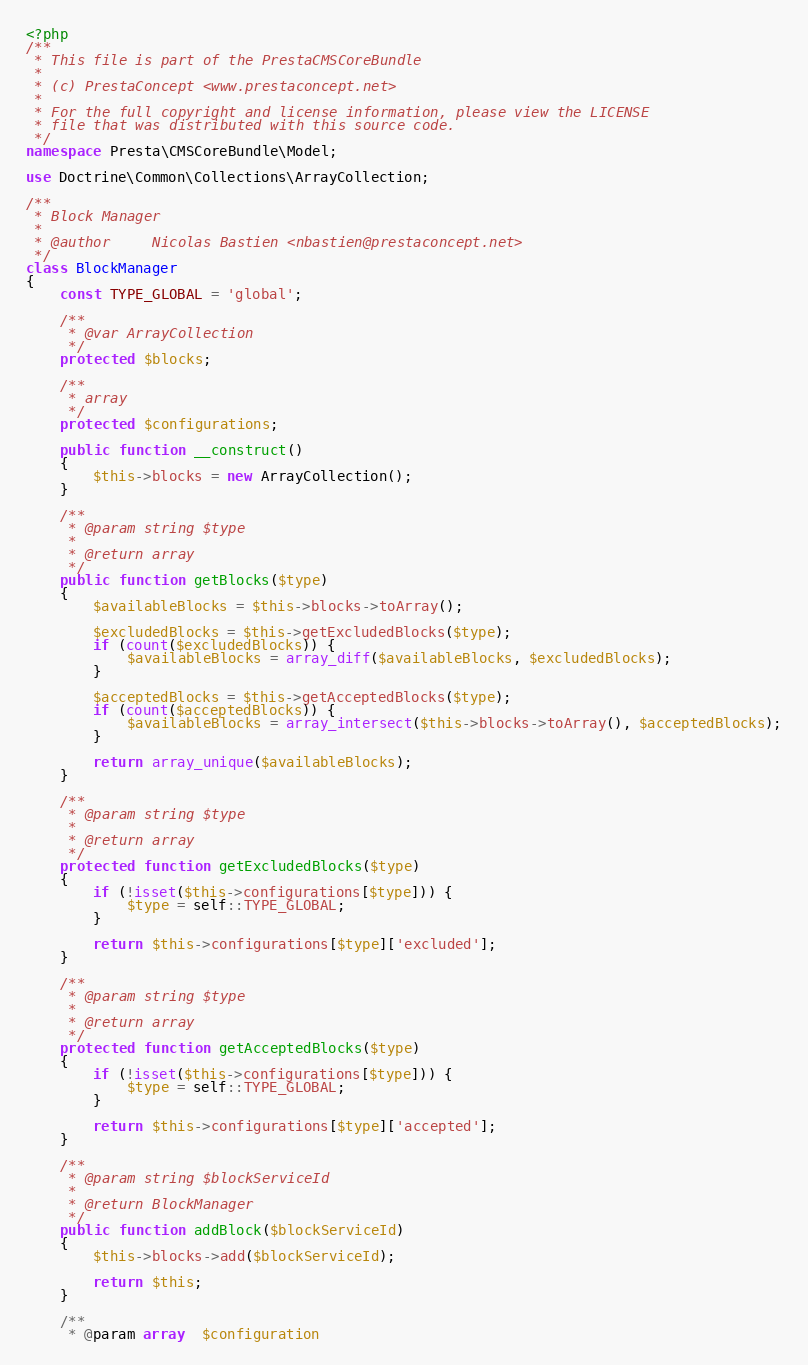Convert code to text. <code><loc_0><loc_0><loc_500><loc_500><_PHP_><?php
/**
 * This file is part of the PrestaCMSCoreBundle
 *
 * (c) PrestaConcept <www.prestaconcept.net>
 *
 * For the full copyright and license information, please view the LICENSE
 * file that was distributed with this source code.
 */
namespace Presta\CMSCoreBundle\Model;

use Doctrine\Common\Collections\ArrayCollection;

/**
 * Block Manager
 *
 * @author     Nicolas Bastien <nbastien@prestaconcept.net>
 */
class BlockManager
{
    const TYPE_GLOBAL = 'global';

    /**
     * @var ArrayCollection
     */
    protected $blocks;

    /**
     * array
     */
    protected $configurations;

    public function __construct()
    {
        $this->blocks = new ArrayCollection();
    }

    /**
     * @param string $type
     *
     * @return array
     */
    public function getBlocks($type)
    {
        $availableBlocks = $this->blocks->toArray();

        $excludedBlocks = $this->getExcludedBlocks($type);
        if (count($excludedBlocks)) {
            $availableBlocks = array_diff($availableBlocks, $excludedBlocks);
        }

        $acceptedBlocks = $this->getAcceptedBlocks($type);
        if (count($acceptedBlocks)) {
            $availableBlocks = array_intersect($this->blocks->toArray(), $acceptedBlocks);
        }

        return array_unique($availableBlocks);
    }

    /**
     * @param string $type
     *
     * @return array
     */
    protected function getExcludedBlocks($type)
    {
        if (!isset($this->configurations[$type])) {
            $type = self::TYPE_GLOBAL;
        }

        return $this->configurations[$type]['excluded'];
    }

    /**
     * @param string $type
     *
     * @return array
     */
    protected function getAcceptedBlocks($type)
    {
        if (!isset($this->configurations[$type])) {
            $type = self::TYPE_GLOBAL;
        }

        return $this->configurations[$type]['accepted'];
    }

    /**
     * @param string $blockServiceId
     *
     * @return BlockManager
     */
    public function addBlock($blockServiceId)
    {
        $this->blocks->add($blockServiceId);

        return $this;
    }

    /**
     * @param array  $configuration</code> 